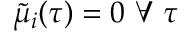<formula> <loc_0><loc_0><loc_500><loc_500>\tilde { \mu } _ { i } ( \tau ) = 0 \forall \tau</formula> 